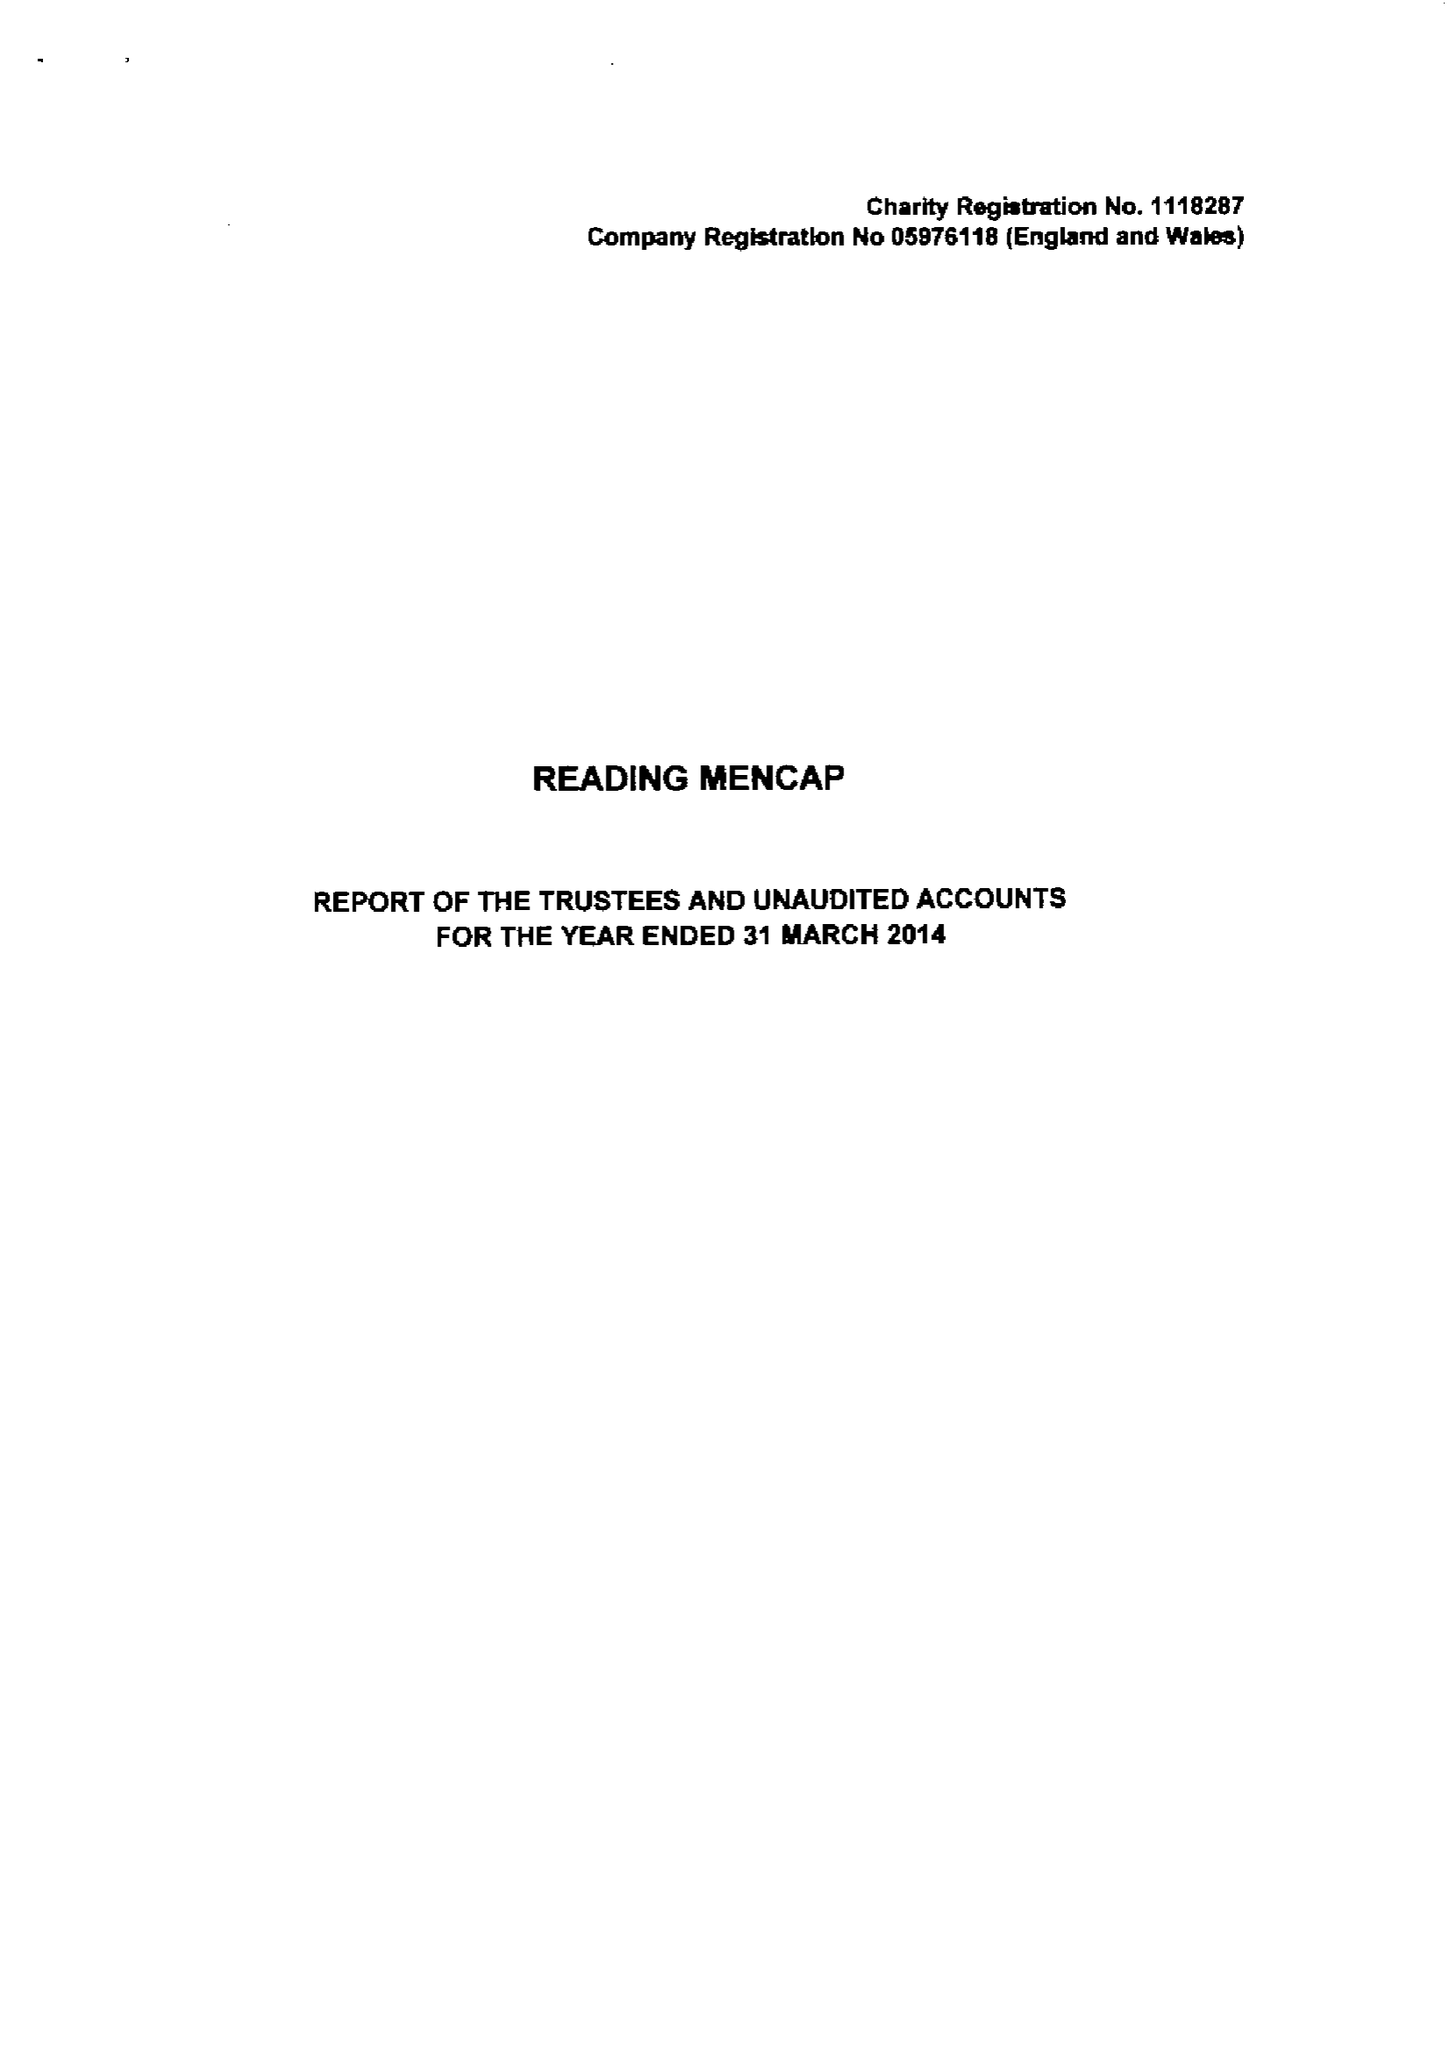What is the value for the income_annually_in_british_pounds?
Answer the question using a single word or phrase. 444640.00 